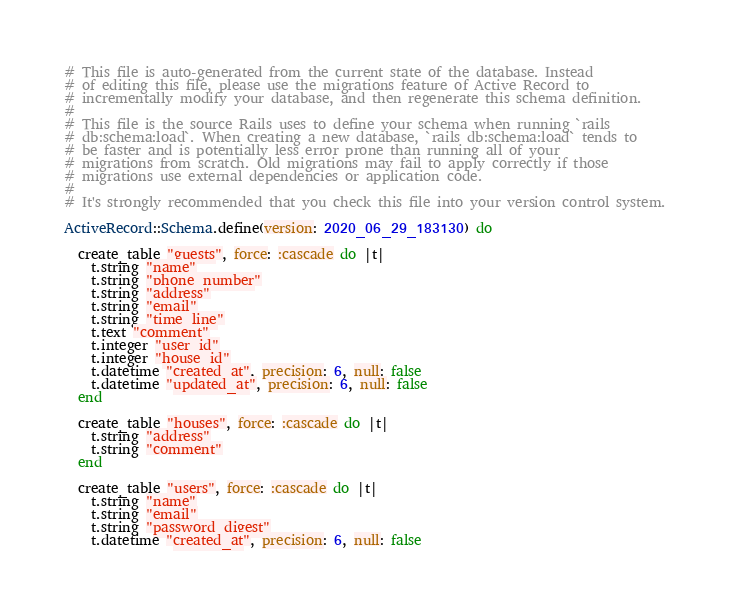<code> <loc_0><loc_0><loc_500><loc_500><_Ruby_># This file is auto-generated from the current state of the database. Instead
# of editing this file, please use the migrations feature of Active Record to
# incrementally modify your database, and then regenerate this schema definition.
#
# This file is the source Rails uses to define your schema when running `rails
# db:schema:load`. When creating a new database, `rails db:schema:load` tends to
# be faster and is potentially less error prone than running all of your
# migrations from scratch. Old migrations may fail to apply correctly if those
# migrations use external dependencies or application code.
#
# It's strongly recommended that you check this file into your version control system.

ActiveRecord::Schema.define(version: 2020_06_29_183130) do

  create_table "guests", force: :cascade do |t|
    t.string "name"
    t.string "phone_number"
    t.string "address"
    t.string "email"
    t.string "time_line"
    t.text "comment"
    t.integer "user_id"
    t.integer "house_id"
    t.datetime "created_at", precision: 6, null: false
    t.datetime "updated_at", precision: 6, null: false
  end

  create_table "houses", force: :cascade do |t|
    t.string "address"
    t.string "comment"
  end

  create_table "users", force: :cascade do |t|
    t.string "name"
    t.string "email"
    t.string "password_digest"
    t.datetime "created_at", precision: 6, null: false</code> 